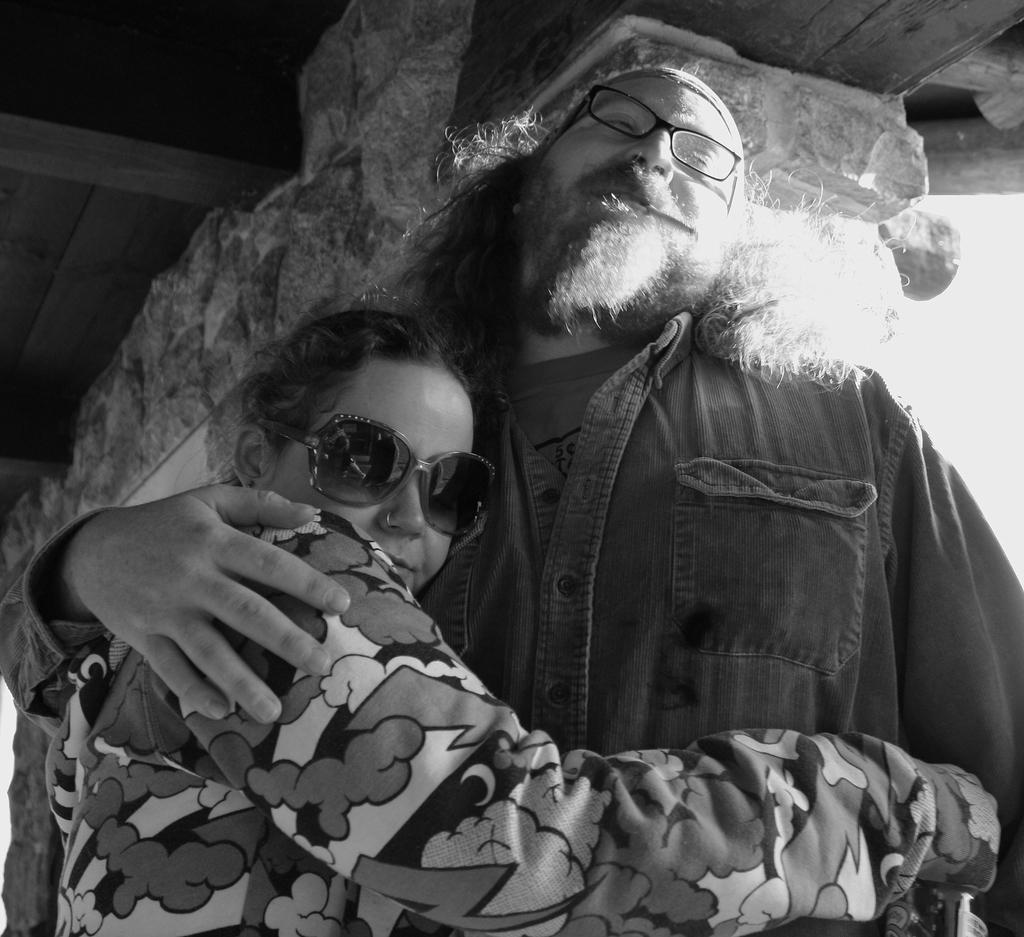How many people are in the image? There are two people in the image. What are the people wearing? Both people are wearing spectacles. What are the people doing in the image? The two people are hugging each other. What can be seen in the background of the image? There is a wall visible in the background of the image. What time is the cannon fired in the image? There is no cannon present in the image, and therefore no time for it to be fired. What is the belief system of the people in the image? We cannot determine the belief system of the people in the image based on the provided facts. 